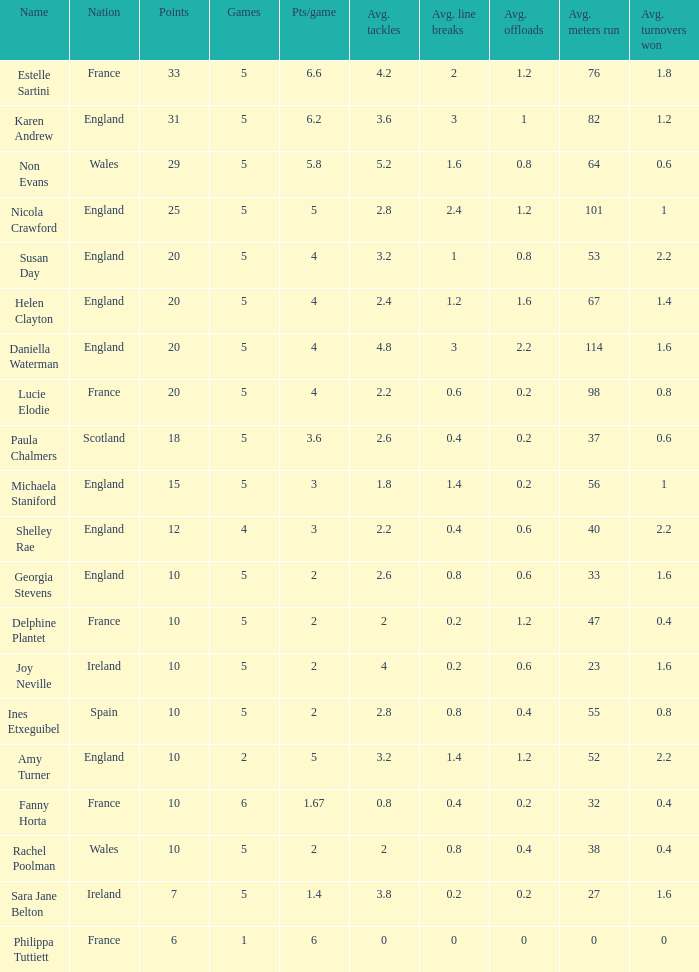Can you tell me the lowest Pts/game that has the Name of philippa tuttiett, and the Points larger then 6? None. 